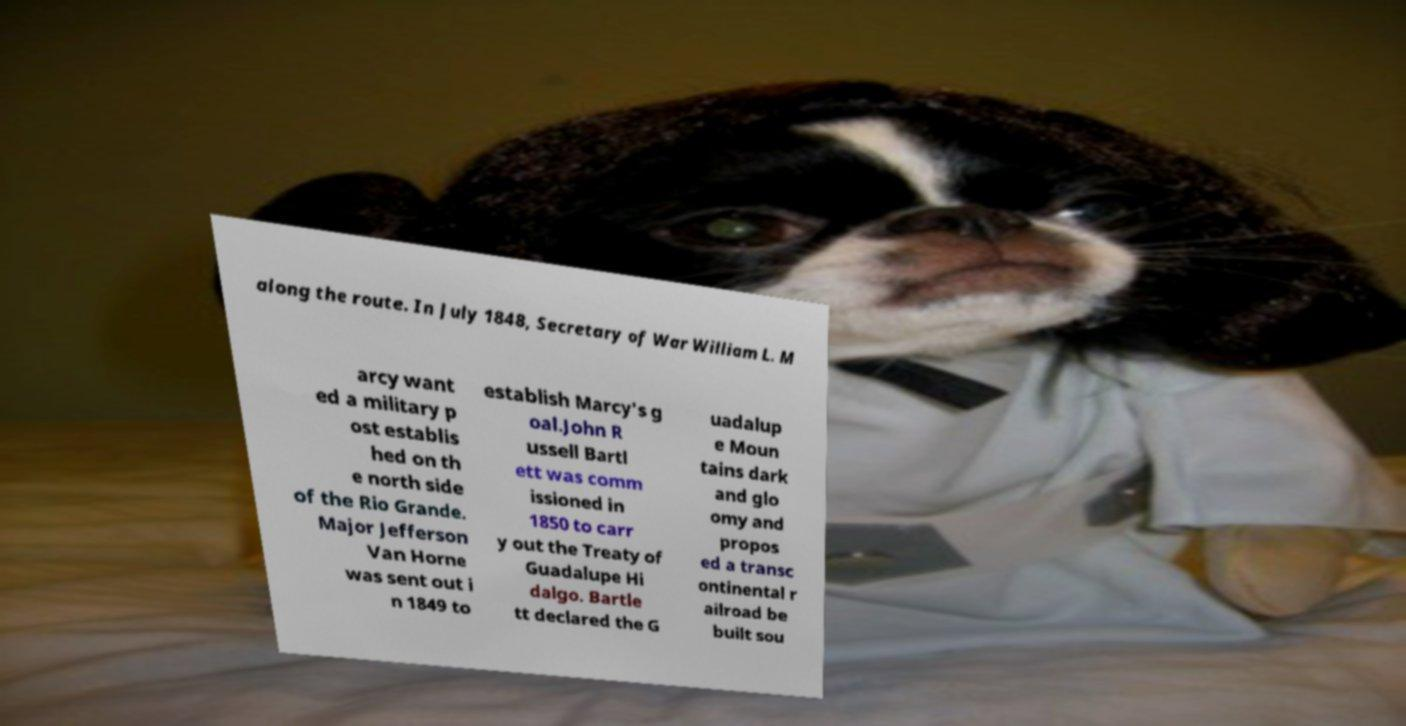I need the written content from this picture converted into text. Can you do that? along the route. In July 1848, Secretary of War William L. M arcy want ed a military p ost establis hed on th e north side of the Rio Grande. Major Jefferson Van Horne was sent out i n 1849 to establish Marcy's g oal.John R ussell Bartl ett was comm issioned in 1850 to carr y out the Treaty of Guadalupe Hi dalgo. Bartle tt declared the G uadalup e Moun tains dark and glo omy and propos ed a transc ontinental r ailroad be built sou 